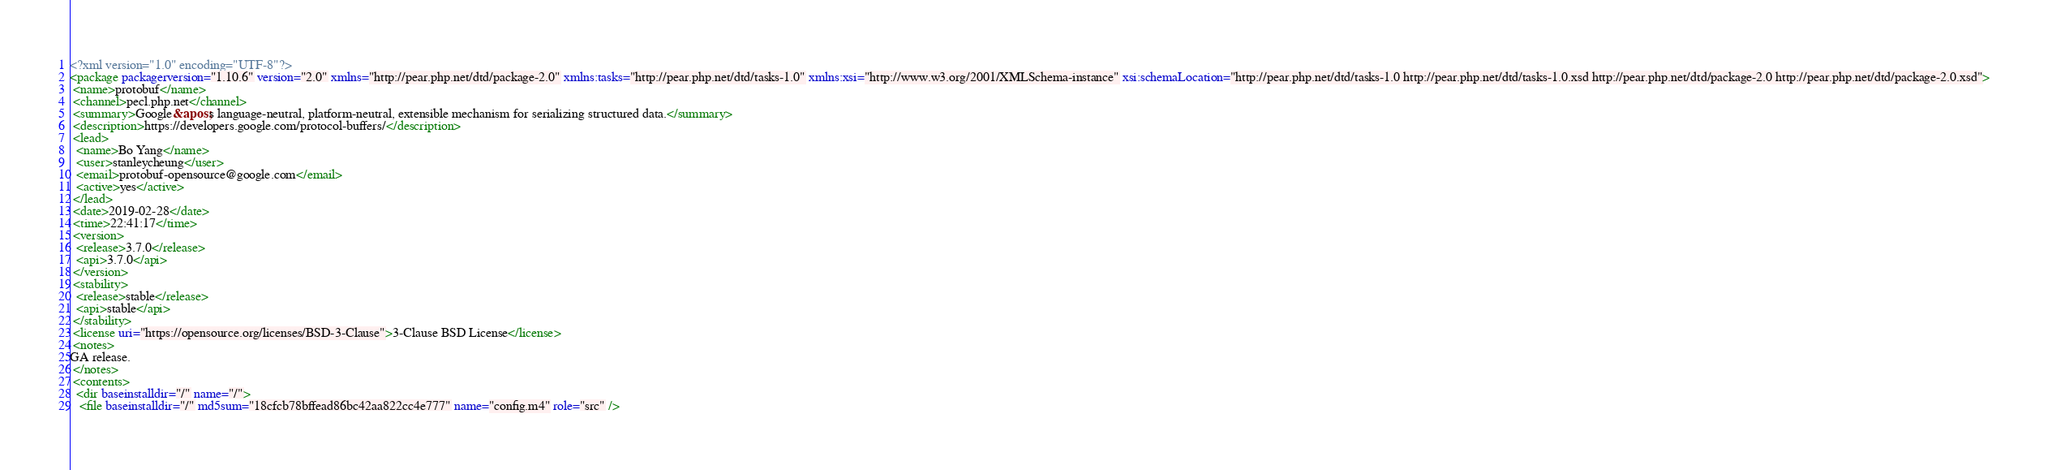Convert code to text. <code><loc_0><loc_0><loc_500><loc_500><_XML_><?xml version="1.0" encoding="UTF-8"?>
<package packagerversion="1.10.6" version="2.0" xmlns="http://pear.php.net/dtd/package-2.0" xmlns:tasks="http://pear.php.net/dtd/tasks-1.0" xmlns:xsi="http://www.w3.org/2001/XMLSchema-instance" xsi:schemaLocation="http://pear.php.net/dtd/tasks-1.0 http://pear.php.net/dtd/tasks-1.0.xsd http://pear.php.net/dtd/package-2.0 http://pear.php.net/dtd/package-2.0.xsd">
 <name>protobuf</name>
 <channel>pecl.php.net</channel>
 <summary>Google&apos;s language-neutral, platform-neutral, extensible mechanism for serializing structured data.</summary>
 <description>https://developers.google.com/protocol-buffers/</description>
 <lead>
  <name>Bo Yang</name>
  <user>stanleycheung</user>
  <email>protobuf-opensource@google.com</email>
  <active>yes</active>
 </lead>
 <date>2019-02-28</date>
 <time>22:41:17</time>
 <version>
  <release>3.7.0</release>
  <api>3.7.0</api>
 </version>
 <stability>
  <release>stable</release>
  <api>stable</api>
 </stability>
 <license uri="https://opensource.org/licenses/BSD-3-Clause">3-Clause BSD License</license>
 <notes>
GA release.
 </notes>
 <contents>
  <dir baseinstalldir="/" name="/">
   <file baseinstalldir="/" md5sum="18cfcb78bffead86bc42aa822cc4e777" name="config.m4" role="src" /></code> 